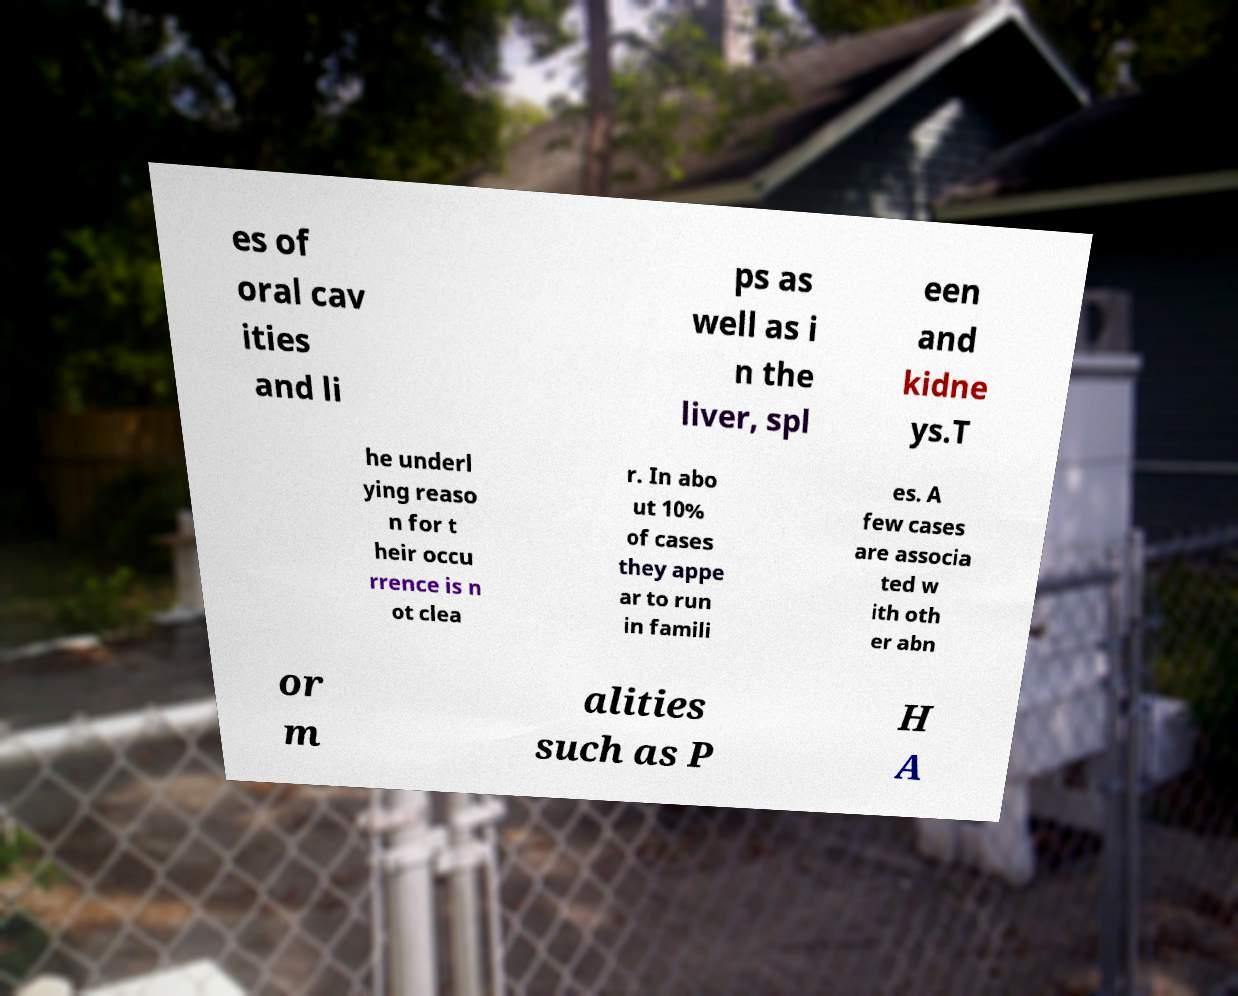There's text embedded in this image that I need extracted. Can you transcribe it verbatim? es of oral cav ities and li ps as well as i n the liver, spl een and kidne ys.T he underl ying reaso n for t heir occu rrence is n ot clea r. In abo ut 10% of cases they appe ar to run in famili es. A few cases are associa ted w ith oth er abn or m alities such as P H A 